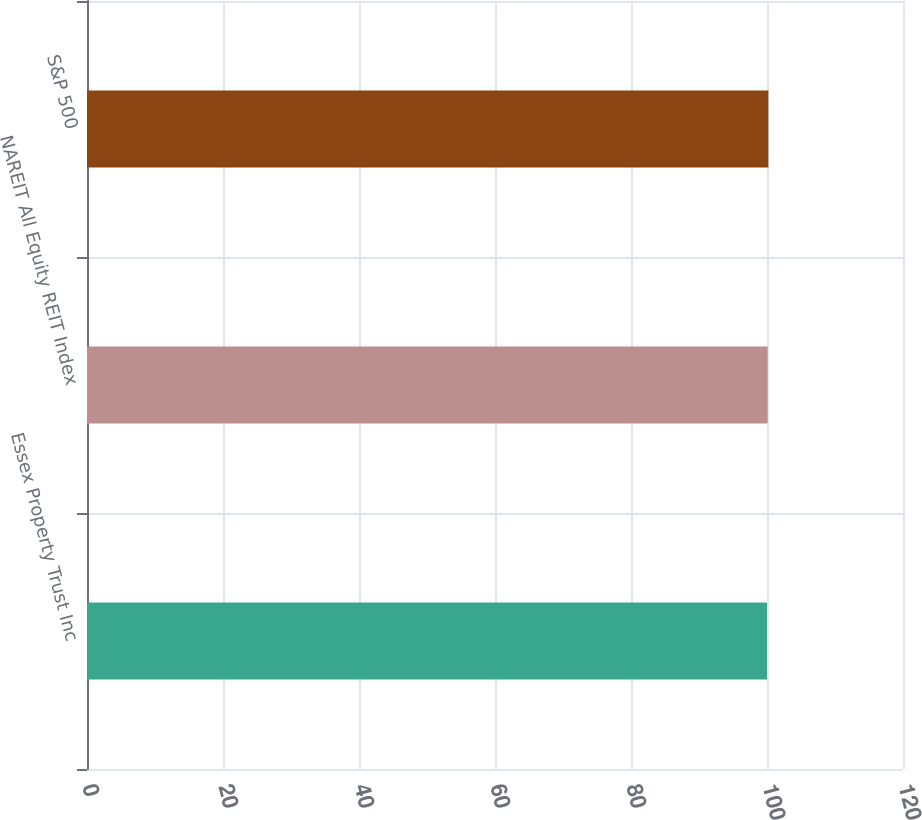<chart> <loc_0><loc_0><loc_500><loc_500><bar_chart><fcel>Essex Property Trust Inc<fcel>NAREIT All Equity REIT Index<fcel>S&P 500<nl><fcel>100<fcel>100.1<fcel>100.2<nl></chart> 